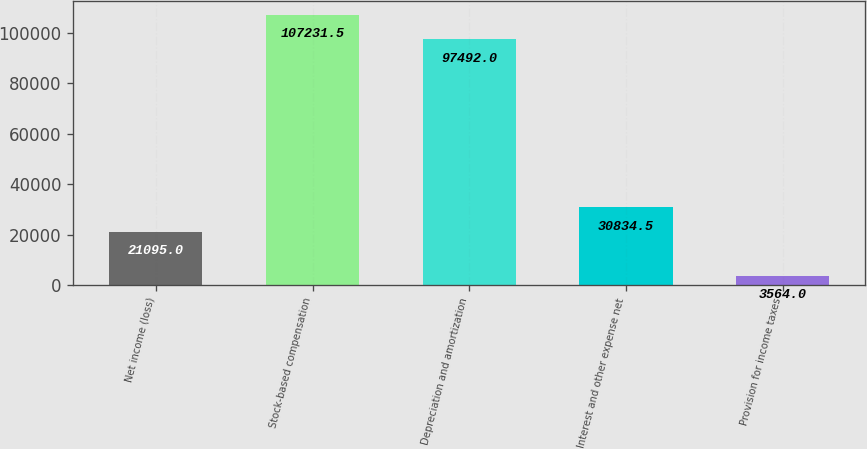Convert chart. <chart><loc_0><loc_0><loc_500><loc_500><bar_chart><fcel>Net income (loss)<fcel>Stock-based compensation<fcel>Depreciation and amortization<fcel>Interest and other expense net<fcel>Provision for income taxes<nl><fcel>21095<fcel>107232<fcel>97492<fcel>30834.5<fcel>3564<nl></chart> 